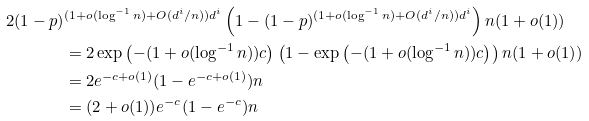Convert formula to latex. <formula><loc_0><loc_0><loc_500><loc_500>2 ( 1 - p ) & ^ { ( 1 + o ( \log ^ { - 1 } n ) + O ( d ^ { i } / n ) ) d ^ { i } } \left ( 1 - ( 1 - p ) ^ { ( 1 + o ( \log ^ { - 1 } n ) + O ( d ^ { i } / n ) ) d ^ { i } } \right ) n ( 1 + o ( 1 ) ) \\ & = 2 \exp \left ( - ( 1 + o ( \log ^ { - 1 } n ) ) c \right ) \left ( 1 - \exp \left ( - ( 1 + o ( \log ^ { - 1 } n ) ) c \right ) \right ) n ( 1 + o ( 1 ) ) \\ & = 2 e ^ { - c + o ( 1 ) } ( 1 - e ^ { - c + o ( 1 ) } ) n \\ & = ( 2 + o ( 1 ) ) e ^ { - c } ( 1 - e ^ { - c } ) n</formula> 